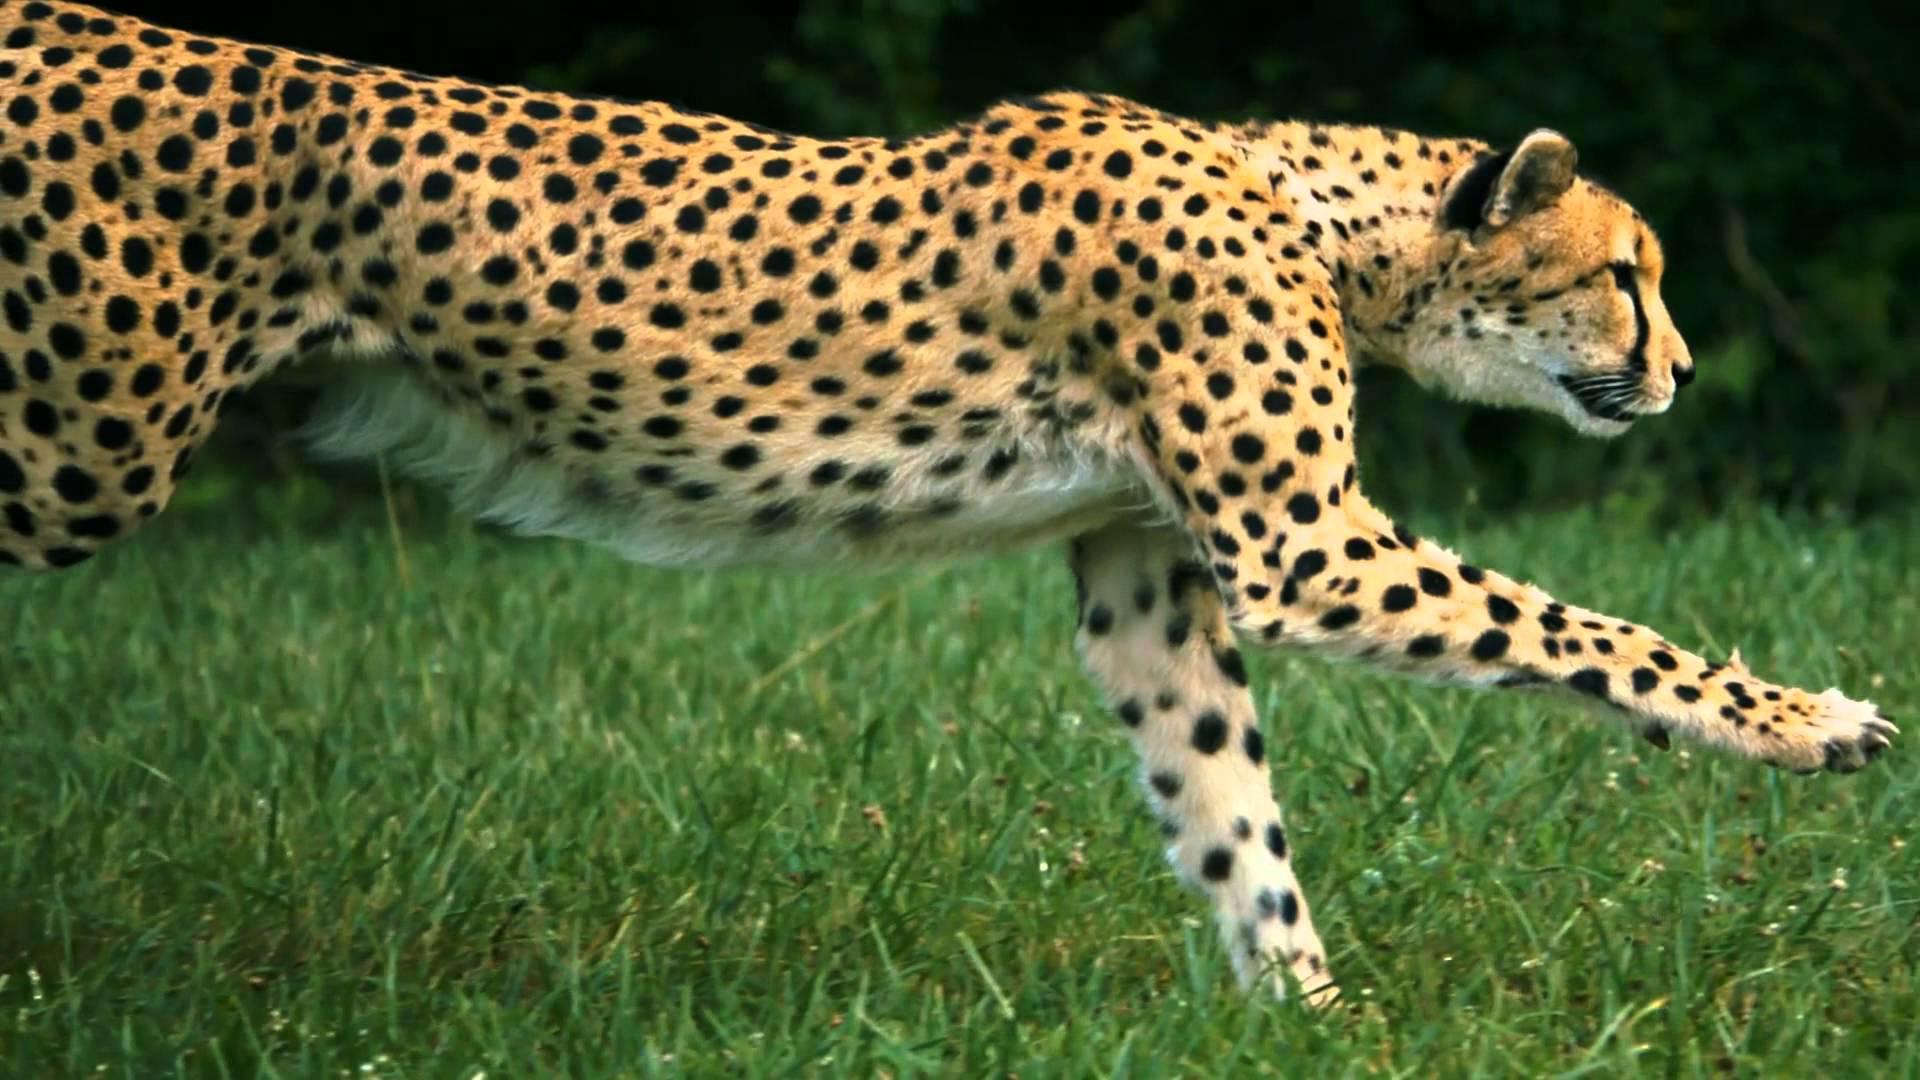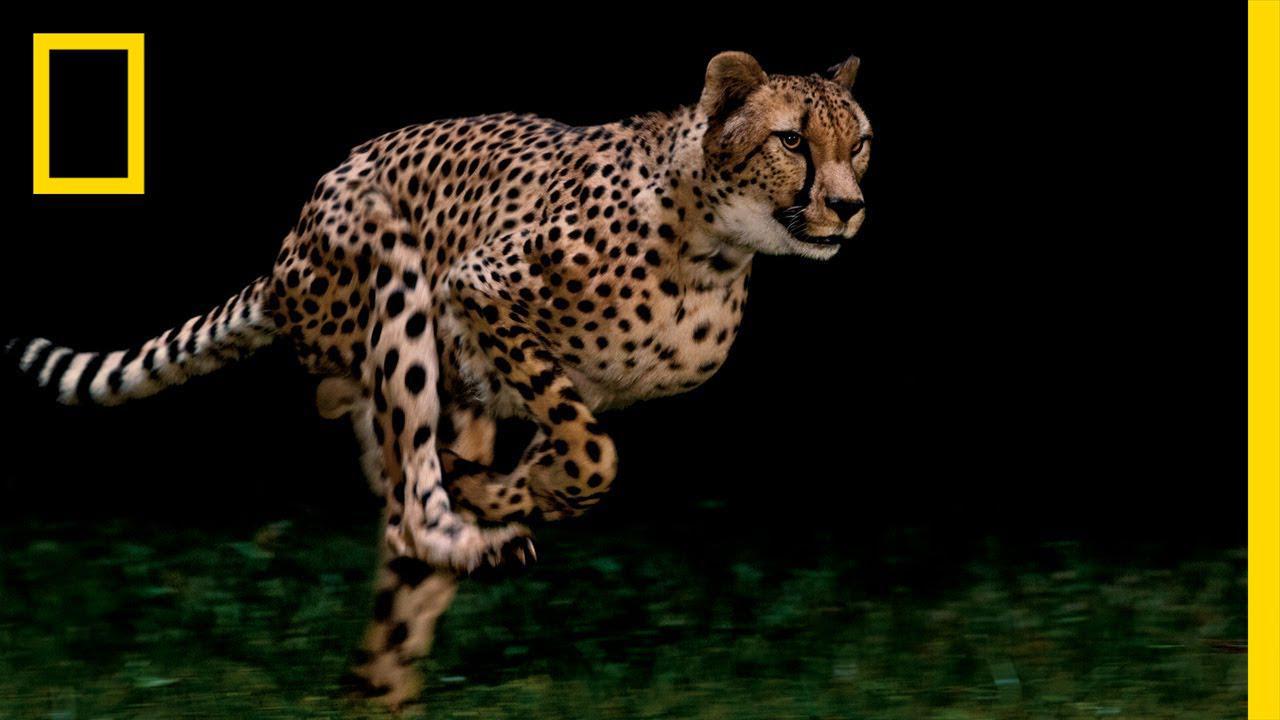The first image is the image on the left, the second image is the image on the right. Analyze the images presented: Is the assertion "All the cheetahs are running the same direction, to the right." valid? Answer yes or no. Yes. 